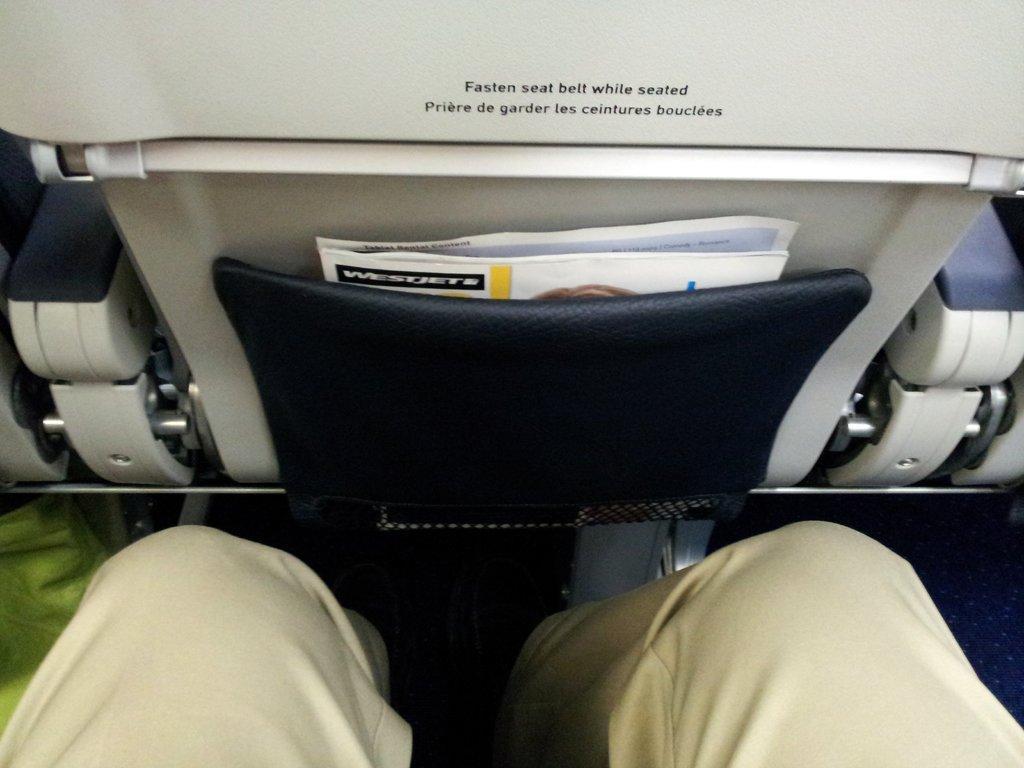Can you describe this image briefly? In this picture I can see a person legs sitting in a vehicle and also we can see the front seat, on which we can see some papers kept in a seat cover. 